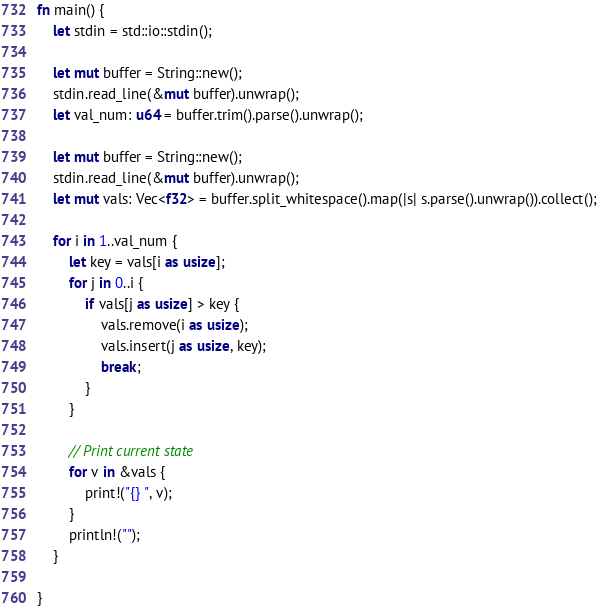Convert code to text. <code><loc_0><loc_0><loc_500><loc_500><_Rust_>fn main() {
    let stdin = std::io::stdin();

    let mut buffer = String::new();
    stdin.read_line(&mut buffer).unwrap();
    let val_num: u64 = buffer.trim().parse().unwrap();

    let mut buffer = String::new();
    stdin.read_line(&mut buffer).unwrap();
    let mut vals: Vec<f32> = buffer.split_whitespace().map(|s| s.parse().unwrap()).collect();

    for i in 1..val_num {
        let key = vals[i as usize];
        for j in 0..i {
            if vals[j as usize] > key {
                vals.remove(i as usize);
                vals.insert(j as usize, key);
                break;
            }
        }

        // Print current state
        for v in &vals {
            print!("{} ", v);
        }
        println!("");
    }

}

</code> 